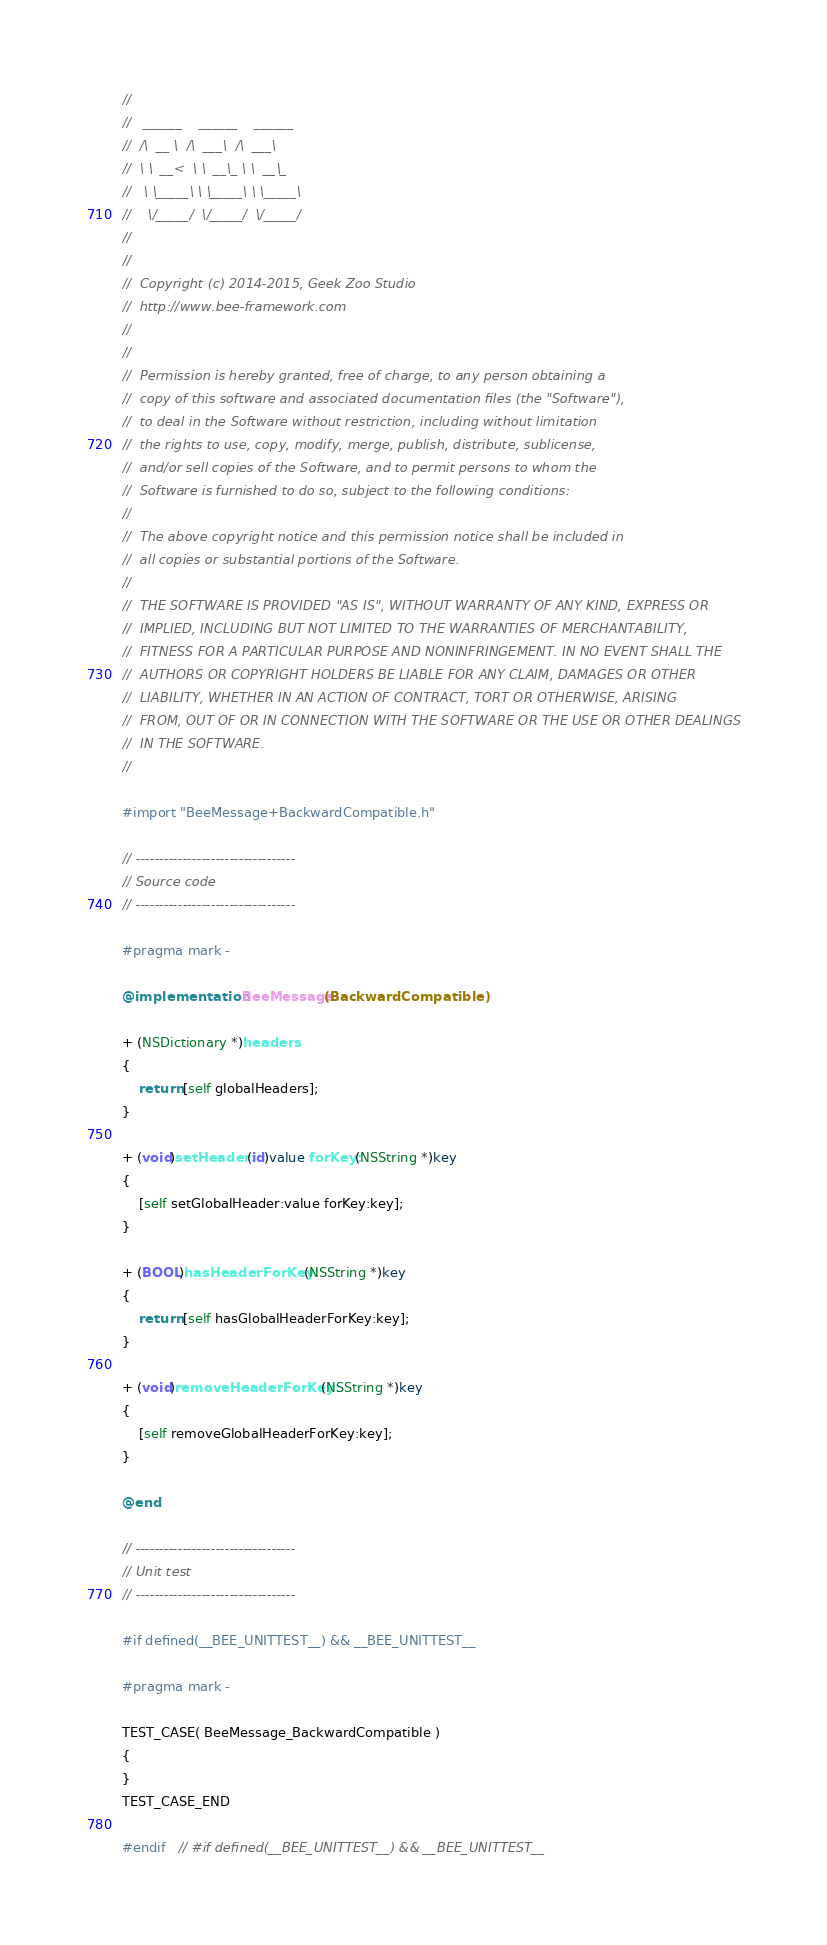Convert code to text. <code><loc_0><loc_0><loc_500><loc_500><_ObjectiveC_>//
//	 ______    ______    ______
//	/\  __ \  /\  ___\  /\  ___\
//	\ \  __<  \ \  __\_ \ \  __\_
//	 \ \_____\ \ \_____\ \ \_____\
//	  \/_____/  \/_____/  \/_____/
//
//
//	Copyright (c) 2014-2015, Geek Zoo Studio
//	http://www.bee-framework.com
//
//
//	Permission is hereby granted, free of charge, to any person obtaining a
//	copy of this software and associated documentation files (the "Software"),
//	to deal in the Software without restriction, including without limitation
//	the rights to use, copy, modify, merge, publish, distribute, sublicense,
//	and/or sell copies of the Software, and to permit persons to whom the
//	Software is furnished to do so, subject to the following conditions:
//
//	The above copyright notice and this permission notice shall be included in
//	all copies or substantial portions of the Software.
//
//	THE SOFTWARE IS PROVIDED "AS IS", WITHOUT WARRANTY OF ANY KIND, EXPRESS OR
//	IMPLIED, INCLUDING BUT NOT LIMITED TO THE WARRANTIES OF MERCHANTABILITY,
//	FITNESS FOR A PARTICULAR PURPOSE AND NONINFRINGEMENT. IN NO EVENT SHALL THE
//	AUTHORS OR COPYRIGHT HOLDERS BE LIABLE FOR ANY CLAIM, DAMAGES OR OTHER
//	LIABILITY, WHETHER IN AN ACTION OF CONTRACT, TORT OR OTHERWISE, ARISING
//	FROM, OUT OF OR IN CONNECTION WITH THE SOFTWARE OR THE USE OR OTHER DEALINGS
//	IN THE SOFTWARE.
//

#import "BeeMessage+BackwardCompatible.h"

// ----------------------------------
// Source code
// ----------------------------------

#pragma mark -

@implementation BeeMessage(BackwardCompatible)

+ (NSDictionary *)headers
{
	return [self globalHeaders];
}

+ (void)setHeader:(id)value forKey:(NSString *)key
{
	[self setGlobalHeader:value forKey:key];
}

+ (BOOL)hasHeaderForKey:(NSString *)key
{
	return [self hasGlobalHeaderForKey:key];
}

+ (void)removeHeaderForKey:(NSString *)key
{
	[self removeGlobalHeaderForKey:key];
}

@end

// ----------------------------------
// Unit test
// ----------------------------------

#if defined(__BEE_UNITTEST__) && __BEE_UNITTEST__

#pragma mark -

TEST_CASE( BeeMessage_BackwardCompatible )
{
}
TEST_CASE_END

#endif	// #if defined(__BEE_UNITTEST__) && __BEE_UNITTEST__
</code> 